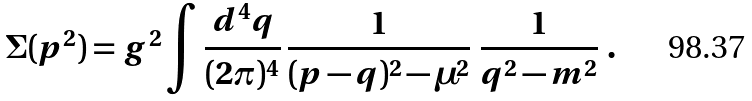Convert formula to latex. <formula><loc_0><loc_0><loc_500><loc_500>\Sigma ( p ^ { 2 } ) = g ^ { 2 } \int \frac { d ^ { 4 } q } { ( 2 \pi ) ^ { 4 } } \, \frac { 1 } { ( p - q ) ^ { 2 } - \mu ^ { 2 } } \ \frac { 1 } { q ^ { 2 } - m ^ { 2 } } \ .</formula> 